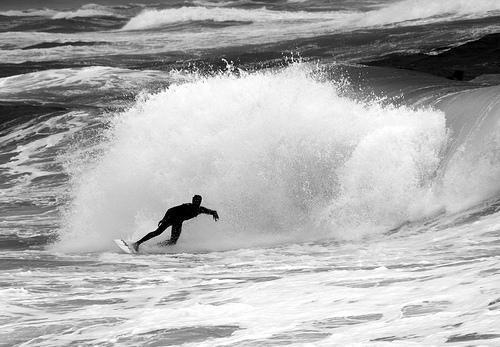How many wakeboard?
Give a very brief answer. 1. 